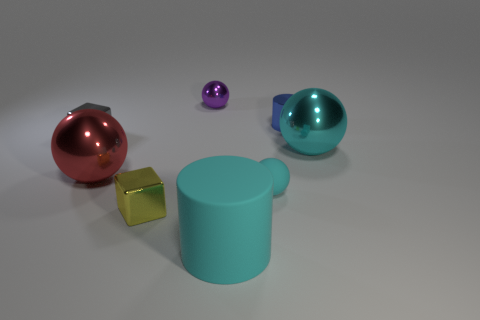There is a big cyan object in front of the small rubber ball; what is its shape?
Your response must be concise. Cylinder. What number of tiny matte objects have the same shape as the small blue metallic thing?
Your answer should be compact. 0. There is a large shiny thing that is on the right side of the small shiny sphere; does it have the same color as the tiny ball that is in front of the red metal ball?
Ensure brevity in your answer.  Yes. What number of objects are either large purple spheres or tiny cyan rubber objects?
Provide a succinct answer. 1. How many large cyan balls have the same material as the red thing?
Ensure brevity in your answer.  1. Is the number of large red things less than the number of tiny green metal blocks?
Ensure brevity in your answer.  No. Is the large red thing on the left side of the large cylinder made of the same material as the small purple ball?
Keep it short and to the point. Yes. What number of cylinders are either small blue metallic objects or large cyan metallic things?
Keep it short and to the point. 1. There is a big object that is both on the right side of the purple sphere and behind the matte cylinder; what shape is it?
Ensure brevity in your answer.  Sphere. What color is the big thing to the left of the tiny purple metallic object that is left of the large cylinder in front of the tiny yellow thing?
Provide a short and direct response. Red. 